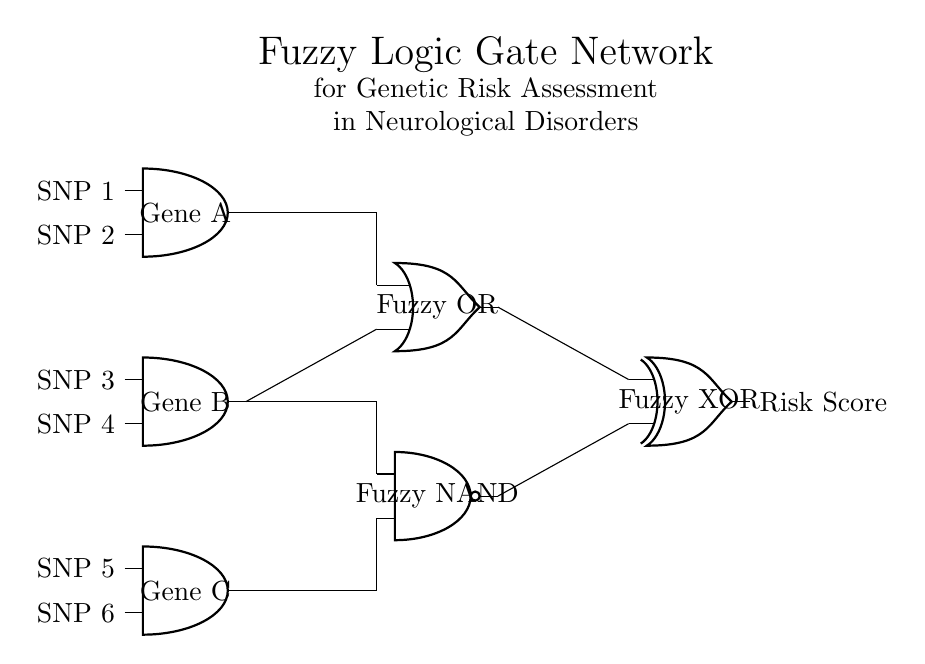What are the three genes represented in the circuit? The circuit has three genes represented as inputs, which are Gene A, Gene B, and Gene C, corresponding to the three AND gates.
Answer: Gene A, Gene B, Gene C What type of logic gates are used in the fuzzy logic network? The fuzzy logic network in the circuit comprises a Fuzzy OR gate, a Fuzzy NAND gate, and a Fuzzy XOR gate indicated by their respective symbols.
Answer: Fuzzy OR, Fuzzy NAND, Fuzzy XOR Which output represents the final risk score? The output from the Fuzzy XOR gate indicates the final risk score, as it is positioned at the end of the circuit and has an output label.
Answer: Risk Score How many inputs are connected to the Fuzzy NAND gate? The Fuzzy NAND gate has two inputs, which come from the outputs of the second AND gate (Gene B) and the third AND gate (Gene C).
Answer: Two inputs What function does the Fuzzy OR gate serve in this network? The Fuzzy OR gate aggregates the risk signals from Gene A and Gene B, indicating that if either gene is contributing positively, the overall risk assessment will rise.
Answer: Aggregation of risk signals Which genes feed into the Fuzzy XOR gate? The Fuzzy XOR gate receives input from the output of the Fuzzy OR gate and the Fuzzy NAND gate, combining the effects of both aggregation and negation of inputs.
Answer: Fuzzy OR output and Fuzzy NAND output What is the significance of using fuzzy logic in this context? Fuzzy logic allows for handling uncertainty and partial truths in genetic data, accommodating the complexity of genetic risk factors in neurological disorders beyond binary logic.
Answer: Handling uncertainty and partial truths 